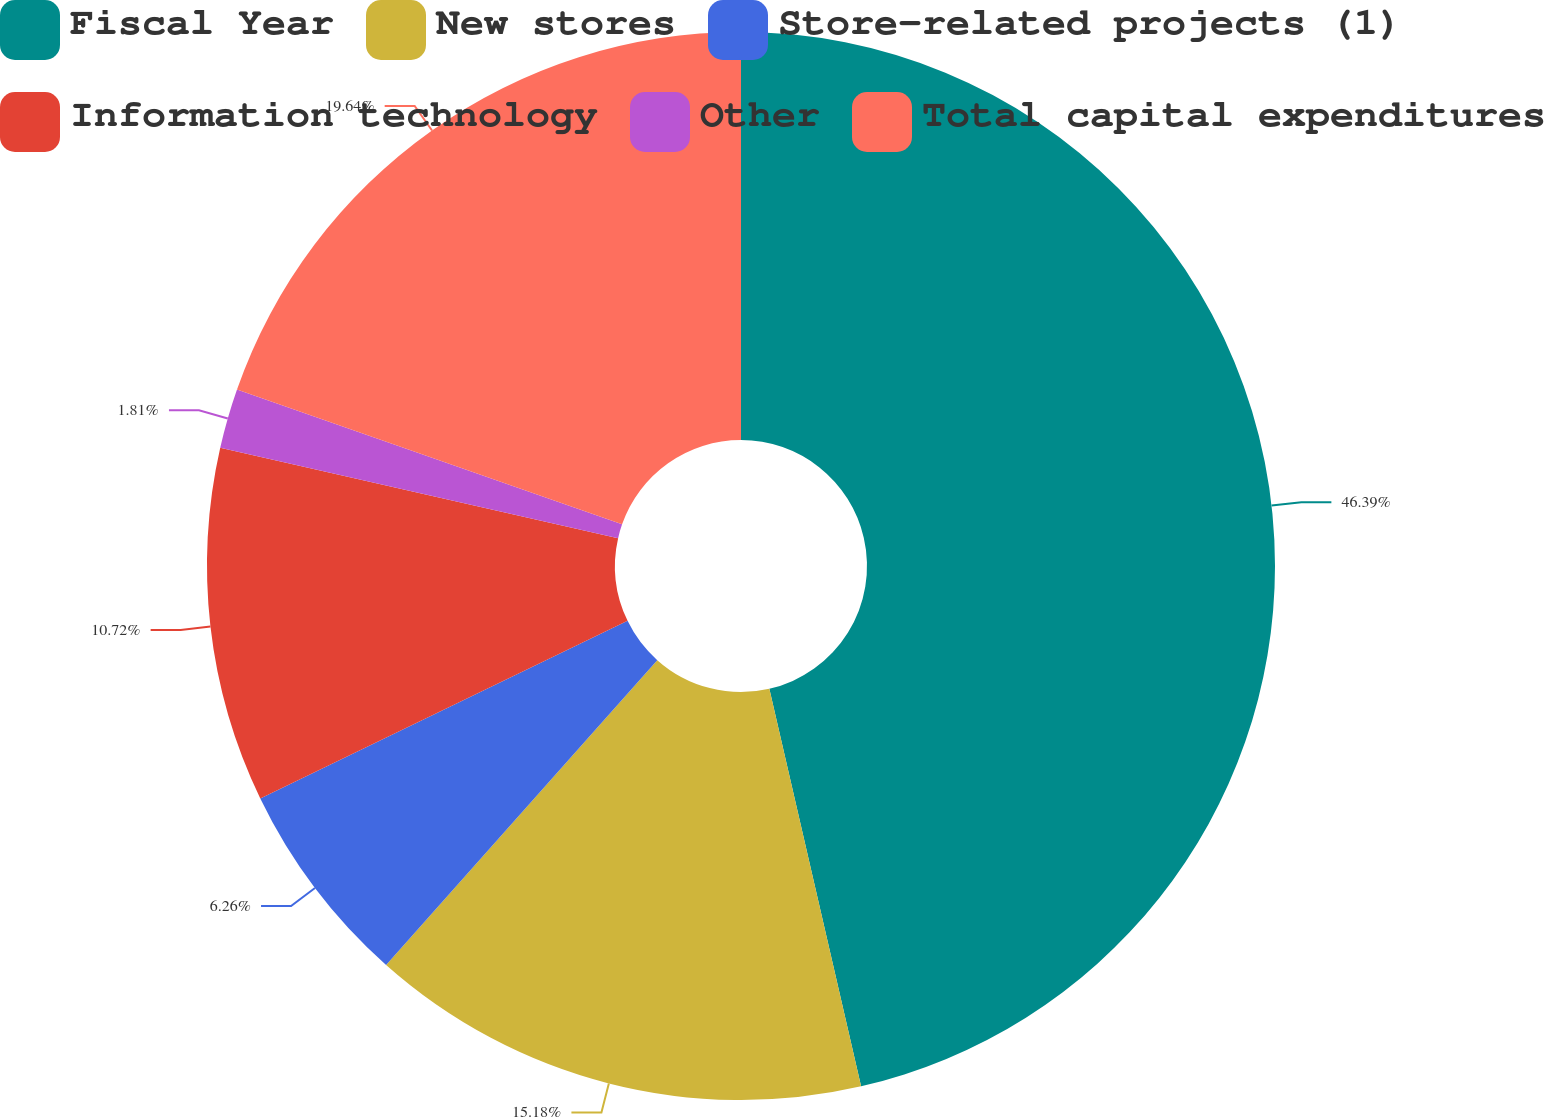<chart> <loc_0><loc_0><loc_500><loc_500><pie_chart><fcel>Fiscal Year<fcel>New stores<fcel>Store-related projects (1)<fcel>Information technology<fcel>Other<fcel>Total capital expenditures<nl><fcel>46.39%<fcel>15.18%<fcel>6.26%<fcel>10.72%<fcel>1.81%<fcel>19.64%<nl></chart> 